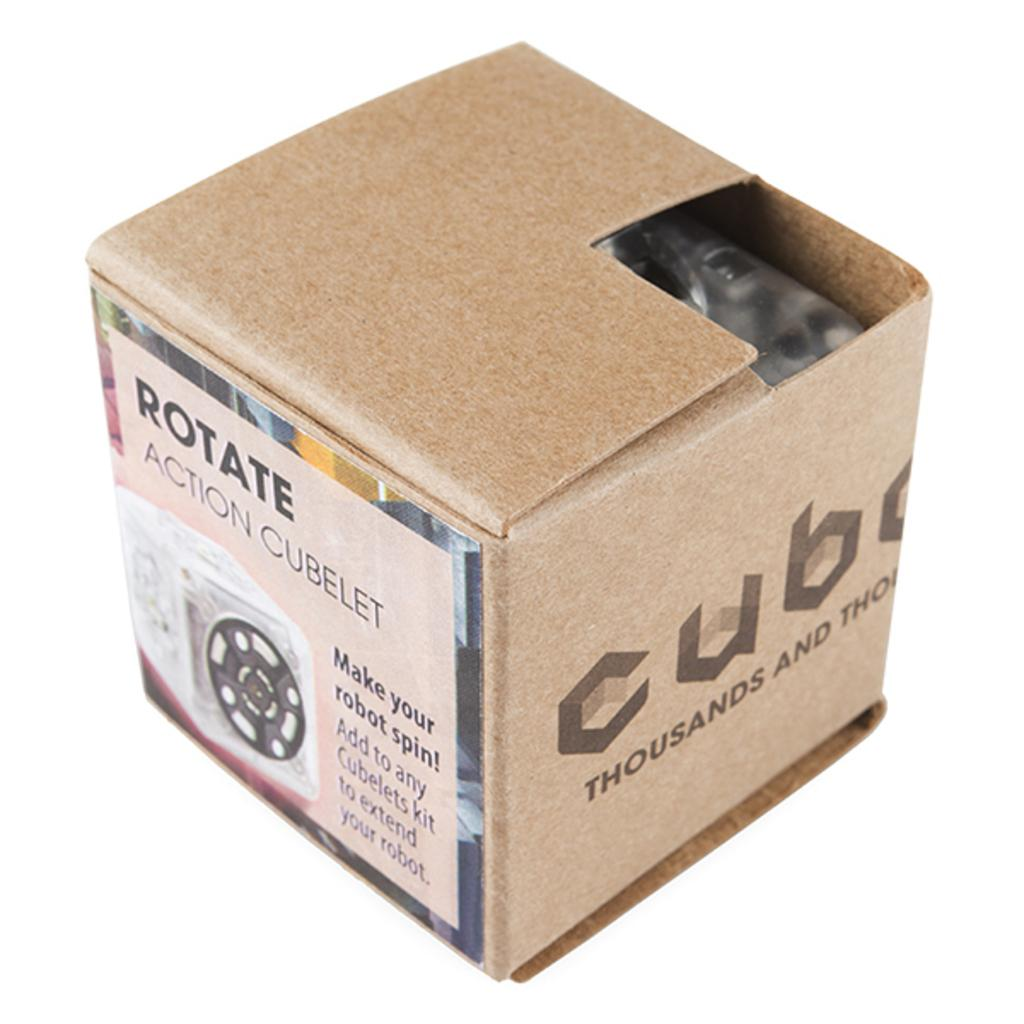Provide a one-sentence caption for the provided image. A brown square box with the brand name CUBE. 